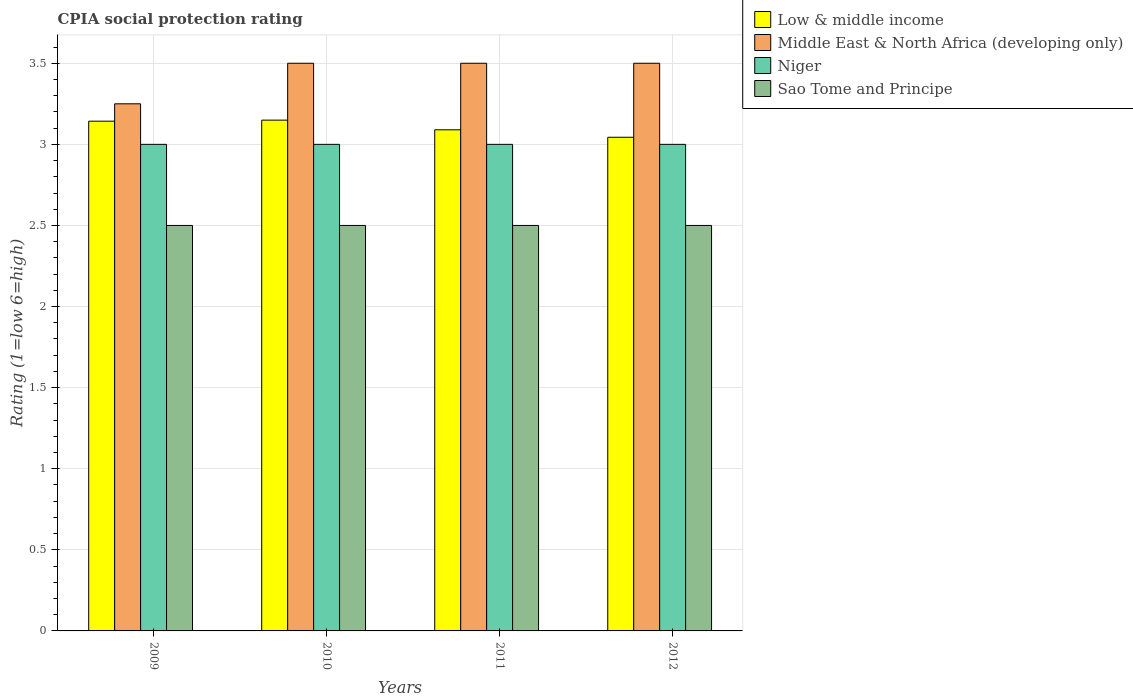How many groups of bars are there?
Provide a succinct answer. 4. Are the number of bars on each tick of the X-axis equal?
Your answer should be compact. Yes. How many bars are there on the 1st tick from the left?
Offer a very short reply. 4. What is the label of the 3rd group of bars from the left?
Keep it short and to the point. 2011. Across all years, what is the maximum CPIA rating in Low & middle income?
Keep it short and to the point. 3.15. What is the total CPIA rating in Low & middle income in the graph?
Your answer should be very brief. 12.43. What is the difference between the CPIA rating in Sao Tome and Principe in 2009 and that in 2010?
Your answer should be very brief. 0. What is the difference between the CPIA rating in Middle East & North Africa (developing only) in 2011 and the CPIA rating in Sao Tome and Principe in 2012?
Offer a very short reply. 1. What is the average CPIA rating in Niger per year?
Give a very brief answer. 3. In the year 2010, what is the difference between the CPIA rating in Middle East & North Africa (developing only) and CPIA rating in Low & middle income?
Make the answer very short. 0.35. In how many years, is the CPIA rating in Sao Tome and Principe greater than 2?
Your response must be concise. 4. Is the difference between the CPIA rating in Middle East & North Africa (developing only) in 2009 and 2010 greater than the difference between the CPIA rating in Low & middle income in 2009 and 2010?
Your response must be concise. No. Is it the case that in every year, the sum of the CPIA rating in Low & middle income and CPIA rating in Middle East & North Africa (developing only) is greater than the sum of CPIA rating in Sao Tome and Principe and CPIA rating in Niger?
Keep it short and to the point. Yes. What does the 2nd bar from the left in 2011 represents?
Keep it short and to the point. Middle East & North Africa (developing only). What does the 3rd bar from the right in 2010 represents?
Provide a succinct answer. Middle East & North Africa (developing only). Are all the bars in the graph horizontal?
Make the answer very short. No. How many years are there in the graph?
Provide a short and direct response. 4. What is the difference between two consecutive major ticks on the Y-axis?
Keep it short and to the point. 0.5. Are the values on the major ticks of Y-axis written in scientific E-notation?
Provide a succinct answer. No. Does the graph contain any zero values?
Your response must be concise. No. Does the graph contain grids?
Provide a short and direct response. Yes. Where does the legend appear in the graph?
Your response must be concise. Top right. How many legend labels are there?
Your response must be concise. 4. What is the title of the graph?
Make the answer very short. CPIA social protection rating. What is the label or title of the X-axis?
Offer a very short reply. Years. What is the label or title of the Y-axis?
Your answer should be compact. Rating (1=low 6=high). What is the Rating (1=low 6=high) in Low & middle income in 2009?
Provide a short and direct response. 3.14. What is the Rating (1=low 6=high) of Middle East & North Africa (developing only) in 2009?
Your answer should be compact. 3.25. What is the Rating (1=low 6=high) in Sao Tome and Principe in 2009?
Your answer should be very brief. 2.5. What is the Rating (1=low 6=high) of Low & middle income in 2010?
Your response must be concise. 3.15. What is the Rating (1=low 6=high) in Middle East & North Africa (developing only) in 2010?
Your answer should be very brief. 3.5. What is the Rating (1=low 6=high) of Low & middle income in 2011?
Keep it short and to the point. 3.09. What is the Rating (1=low 6=high) in Niger in 2011?
Your answer should be very brief. 3. What is the Rating (1=low 6=high) in Low & middle income in 2012?
Your response must be concise. 3.04. What is the Rating (1=low 6=high) in Niger in 2012?
Ensure brevity in your answer.  3. Across all years, what is the maximum Rating (1=low 6=high) in Low & middle income?
Provide a succinct answer. 3.15. Across all years, what is the minimum Rating (1=low 6=high) of Low & middle income?
Provide a short and direct response. 3.04. Across all years, what is the minimum Rating (1=low 6=high) in Niger?
Provide a succinct answer. 3. Across all years, what is the minimum Rating (1=low 6=high) of Sao Tome and Principe?
Keep it short and to the point. 2.5. What is the total Rating (1=low 6=high) in Low & middle income in the graph?
Your answer should be very brief. 12.43. What is the total Rating (1=low 6=high) in Middle East & North Africa (developing only) in the graph?
Your answer should be very brief. 13.75. What is the total Rating (1=low 6=high) of Niger in the graph?
Give a very brief answer. 12. What is the difference between the Rating (1=low 6=high) in Low & middle income in 2009 and that in 2010?
Provide a succinct answer. -0.01. What is the difference between the Rating (1=low 6=high) in Niger in 2009 and that in 2010?
Ensure brevity in your answer.  0. What is the difference between the Rating (1=low 6=high) of Low & middle income in 2009 and that in 2011?
Provide a succinct answer. 0.05. What is the difference between the Rating (1=low 6=high) of Middle East & North Africa (developing only) in 2009 and that in 2011?
Offer a terse response. -0.25. What is the difference between the Rating (1=low 6=high) of Niger in 2009 and that in 2011?
Your answer should be compact. 0. What is the difference between the Rating (1=low 6=high) of Low & middle income in 2009 and that in 2012?
Make the answer very short. 0.1. What is the difference between the Rating (1=low 6=high) in Middle East & North Africa (developing only) in 2009 and that in 2012?
Provide a short and direct response. -0.25. What is the difference between the Rating (1=low 6=high) in Sao Tome and Principe in 2009 and that in 2012?
Your answer should be compact. 0. What is the difference between the Rating (1=low 6=high) in Low & middle income in 2010 and that in 2011?
Give a very brief answer. 0.06. What is the difference between the Rating (1=low 6=high) of Niger in 2010 and that in 2011?
Provide a short and direct response. 0. What is the difference between the Rating (1=low 6=high) in Low & middle income in 2010 and that in 2012?
Your response must be concise. 0.11. What is the difference between the Rating (1=low 6=high) in Middle East & North Africa (developing only) in 2010 and that in 2012?
Offer a very short reply. 0. What is the difference between the Rating (1=low 6=high) of Niger in 2010 and that in 2012?
Offer a terse response. 0. What is the difference between the Rating (1=low 6=high) of Low & middle income in 2011 and that in 2012?
Keep it short and to the point. 0.05. What is the difference between the Rating (1=low 6=high) in Middle East & North Africa (developing only) in 2011 and that in 2012?
Make the answer very short. 0. What is the difference between the Rating (1=low 6=high) of Sao Tome and Principe in 2011 and that in 2012?
Offer a terse response. 0. What is the difference between the Rating (1=low 6=high) in Low & middle income in 2009 and the Rating (1=low 6=high) in Middle East & North Africa (developing only) in 2010?
Provide a short and direct response. -0.36. What is the difference between the Rating (1=low 6=high) in Low & middle income in 2009 and the Rating (1=low 6=high) in Niger in 2010?
Give a very brief answer. 0.14. What is the difference between the Rating (1=low 6=high) of Low & middle income in 2009 and the Rating (1=low 6=high) of Sao Tome and Principe in 2010?
Your answer should be very brief. 0.64. What is the difference between the Rating (1=low 6=high) of Middle East & North Africa (developing only) in 2009 and the Rating (1=low 6=high) of Niger in 2010?
Give a very brief answer. 0.25. What is the difference between the Rating (1=low 6=high) in Niger in 2009 and the Rating (1=low 6=high) in Sao Tome and Principe in 2010?
Provide a short and direct response. 0.5. What is the difference between the Rating (1=low 6=high) of Low & middle income in 2009 and the Rating (1=low 6=high) of Middle East & North Africa (developing only) in 2011?
Make the answer very short. -0.36. What is the difference between the Rating (1=low 6=high) in Low & middle income in 2009 and the Rating (1=low 6=high) in Niger in 2011?
Keep it short and to the point. 0.14. What is the difference between the Rating (1=low 6=high) in Low & middle income in 2009 and the Rating (1=low 6=high) in Sao Tome and Principe in 2011?
Offer a terse response. 0.64. What is the difference between the Rating (1=low 6=high) in Middle East & North Africa (developing only) in 2009 and the Rating (1=low 6=high) in Sao Tome and Principe in 2011?
Give a very brief answer. 0.75. What is the difference between the Rating (1=low 6=high) of Niger in 2009 and the Rating (1=low 6=high) of Sao Tome and Principe in 2011?
Provide a succinct answer. 0.5. What is the difference between the Rating (1=low 6=high) in Low & middle income in 2009 and the Rating (1=low 6=high) in Middle East & North Africa (developing only) in 2012?
Offer a terse response. -0.36. What is the difference between the Rating (1=low 6=high) in Low & middle income in 2009 and the Rating (1=low 6=high) in Niger in 2012?
Keep it short and to the point. 0.14. What is the difference between the Rating (1=low 6=high) in Low & middle income in 2009 and the Rating (1=low 6=high) in Sao Tome and Principe in 2012?
Provide a short and direct response. 0.64. What is the difference between the Rating (1=low 6=high) of Low & middle income in 2010 and the Rating (1=low 6=high) of Middle East & North Africa (developing only) in 2011?
Your answer should be very brief. -0.35. What is the difference between the Rating (1=low 6=high) of Low & middle income in 2010 and the Rating (1=low 6=high) of Niger in 2011?
Keep it short and to the point. 0.15. What is the difference between the Rating (1=low 6=high) of Low & middle income in 2010 and the Rating (1=low 6=high) of Sao Tome and Principe in 2011?
Keep it short and to the point. 0.65. What is the difference between the Rating (1=low 6=high) in Low & middle income in 2010 and the Rating (1=low 6=high) in Middle East & North Africa (developing only) in 2012?
Your answer should be compact. -0.35. What is the difference between the Rating (1=low 6=high) of Low & middle income in 2010 and the Rating (1=low 6=high) of Niger in 2012?
Your response must be concise. 0.15. What is the difference between the Rating (1=low 6=high) in Low & middle income in 2010 and the Rating (1=low 6=high) in Sao Tome and Principe in 2012?
Keep it short and to the point. 0.65. What is the difference between the Rating (1=low 6=high) of Middle East & North Africa (developing only) in 2010 and the Rating (1=low 6=high) of Niger in 2012?
Your answer should be compact. 0.5. What is the difference between the Rating (1=low 6=high) in Niger in 2010 and the Rating (1=low 6=high) in Sao Tome and Principe in 2012?
Offer a terse response. 0.5. What is the difference between the Rating (1=low 6=high) of Low & middle income in 2011 and the Rating (1=low 6=high) of Middle East & North Africa (developing only) in 2012?
Provide a succinct answer. -0.41. What is the difference between the Rating (1=low 6=high) of Low & middle income in 2011 and the Rating (1=low 6=high) of Niger in 2012?
Give a very brief answer. 0.09. What is the difference between the Rating (1=low 6=high) in Low & middle income in 2011 and the Rating (1=low 6=high) in Sao Tome and Principe in 2012?
Your response must be concise. 0.59. What is the difference between the Rating (1=low 6=high) in Middle East & North Africa (developing only) in 2011 and the Rating (1=low 6=high) in Niger in 2012?
Make the answer very short. 0.5. What is the average Rating (1=low 6=high) of Low & middle income per year?
Provide a short and direct response. 3.11. What is the average Rating (1=low 6=high) of Middle East & North Africa (developing only) per year?
Your response must be concise. 3.44. What is the average Rating (1=low 6=high) in Niger per year?
Ensure brevity in your answer.  3. What is the average Rating (1=low 6=high) of Sao Tome and Principe per year?
Provide a short and direct response. 2.5. In the year 2009, what is the difference between the Rating (1=low 6=high) of Low & middle income and Rating (1=low 6=high) of Middle East & North Africa (developing only)?
Offer a terse response. -0.11. In the year 2009, what is the difference between the Rating (1=low 6=high) in Low & middle income and Rating (1=low 6=high) in Niger?
Your answer should be compact. 0.14. In the year 2009, what is the difference between the Rating (1=low 6=high) of Low & middle income and Rating (1=low 6=high) of Sao Tome and Principe?
Keep it short and to the point. 0.64. In the year 2009, what is the difference between the Rating (1=low 6=high) in Middle East & North Africa (developing only) and Rating (1=low 6=high) in Niger?
Ensure brevity in your answer.  0.25. In the year 2010, what is the difference between the Rating (1=low 6=high) in Low & middle income and Rating (1=low 6=high) in Middle East & North Africa (developing only)?
Make the answer very short. -0.35. In the year 2010, what is the difference between the Rating (1=low 6=high) in Low & middle income and Rating (1=low 6=high) in Niger?
Ensure brevity in your answer.  0.15. In the year 2010, what is the difference between the Rating (1=low 6=high) in Low & middle income and Rating (1=low 6=high) in Sao Tome and Principe?
Keep it short and to the point. 0.65. In the year 2010, what is the difference between the Rating (1=low 6=high) of Middle East & North Africa (developing only) and Rating (1=low 6=high) of Niger?
Provide a succinct answer. 0.5. In the year 2010, what is the difference between the Rating (1=low 6=high) of Middle East & North Africa (developing only) and Rating (1=low 6=high) of Sao Tome and Principe?
Keep it short and to the point. 1. In the year 2011, what is the difference between the Rating (1=low 6=high) in Low & middle income and Rating (1=low 6=high) in Middle East & North Africa (developing only)?
Offer a very short reply. -0.41. In the year 2011, what is the difference between the Rating (1=low 6=high) of Low & middle income and Rating (1=low 6=high) of Niger?
Offer a terse response. 0.09. In the year 2011, what is the difference between the Rating (1=low 6=high) of Low & middle income and Rating (1=low 6=high) of Sao Tome and Principe?
Provide a succinct answer. 0.59. In the year 2011, what is the difference between the Rating (1=low 6=high) of Middle East & North Africa (developing only) and Rating (1=low 6=high) of Niger?
Provide a short and direct response. 0.5. In the year 2011, what is the difference between the Rating (1=low 6=high) in Middle East & North Africa (developing only) and Rating (1=low 6=high) in Sao Tome and Principe?
Keep it short and to the point. 1. In the year 2011, what is the difference between the Rating (1=low 6=high) of Niger and Rating (1=low 6=high) of Sao Tome and Principe?
Make the answer very short. 0.5. In the year 2012, what is the difference between the Rating (1=low 6=high) in Low & middle income and Rating (1=low 6=high) in Middle East & North Africa (developing only)?
Your answer should be compact. -0.46. In the year 2012, what is the difference between the Rating (1=low 6=high) in Low & middle income and Rating (1=low 6=high) in Niger?
Keep it short and to the point. 0.04. In the year 2012, what is the difference between the Rating (1=low 6=high) in Low & middle income and Rating (1=low 6=high) in Sao Tome and Principe?
Offer a terse response. 0.54. In the year 2012, what is the difference between the Rating (1=low 6=high) of Middle East & North Africa (developing only) and Rating (1=low 6=high) of Niger?
Provide a succinct answer. 0.5. What is the ratio of the Rating (1=low 6=high) in Sao Tome and Principe in 2009 to that in 2010?
Keep it short and to the point. 1. What is the ratio of the Rating (1=low 6=high) in Low & middle income in 2009 to that in 2011?
Your answer should be compact. 1.02. What is the ratio of the Rating (1=low 6=high) in Middle East & North Africa (developing only) in 2009 to that in 2011?
Your response must be concise. 0.93. What is the ratio of the Rating (1=low 6=high) of Niger in 2009 to that in 2011?
Provide a short and direct response. 1. What is the ratio of the Rating (1=low 6=high) in Low & middle income in 2009 to that in 2012?
Make the answer very short. 1.03. What is the ratio of the Rating (1=low 6=high) in Middle East & North Africa (developing only) in 2009 to that in 2012?
Provide a short and direct response. 0.93. What is the ratio of the Rating (1=low 6=high) of Low & middle income in 2010 to that in 2011?
Your answer should be compact. 1.02. What is the ratio of the Rating (1=low 6=high) of Sao Tome and Principe in 2010 to that in 2011?
Keep it short and to the point. 1. What is the ratio of the Rating (1=low 6=high) in Low & middle income in 2010 to that in 2012?
Keep it short and to the point. 1.03. What is the ratio of the Rating (1=low 6=high) of Middle East & North Africa (developing only) in 2010 to that in 2012?
Your answer should be compact. 1. What is the ratio of the Rating (1=low 6=high) of Niger in 2010 to that in 2012?
Keep it short and to the point. 1. What is the ratio of the Rating (1=low 6=high) of Low & middle income in 2011 to that in 2012?
Provide a succinct answer. 1.02. What is the ratio of the Rating (1=low 6=high) of Niger in 2011 to that in 2012?
Your response must be concise. 1. What is the difference between the highest and the second highest Rating (1=low 6=high) of Low & middle income?
Offer a very short reply. 0.01. What is the difference between the highest and the second highest Rating (1=low 6=high) in Niger?
Make the answer very short. 0. What is the difference between the highest and the lowest Rating (1=low 6=high) of Low & middle income?
Keep it short and to the point. 0.11. What is the difference between the highest and the lowest Rating (1=low 6=high) of Niger?
Keep it short and to the point. 0. 